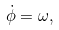<formula> <loc_0><loc_0><loc_500><loc_500>\dot { \phi } = \omega ,</formula> 